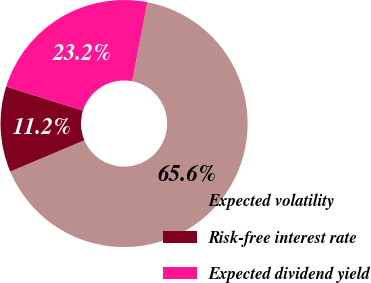<chart> <loc_0><loc_0><loc_500><loc_500><pie_chart><fcel>Expected volatility<fcel>Risk-free interest rate<fcel>Expected dividend yield<nl><fcel>65.64%<fcel>11.2%<fcel>23.17%<nl></chart> 